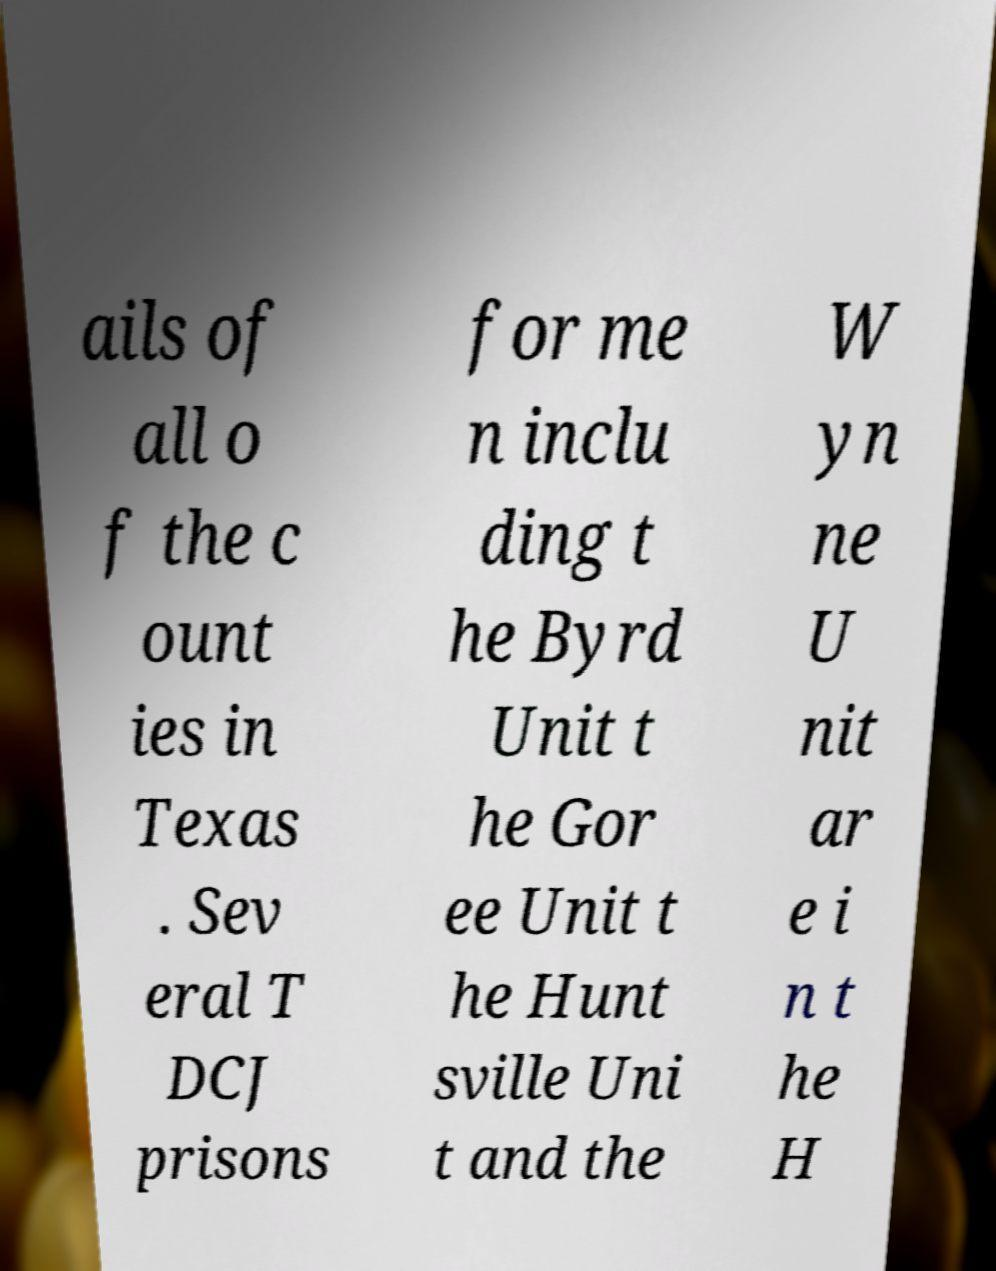What messages or text are displayed in this image? I need them in a readable, typed format. ails of all o f the c ount ies in Texas . Sev eral T DCJ prisons for me n inclu ding t he Byrd Unit t he Gor ee Unit t he Hunt sville Uni t and the W yn ne U nit ar e i n t he H 